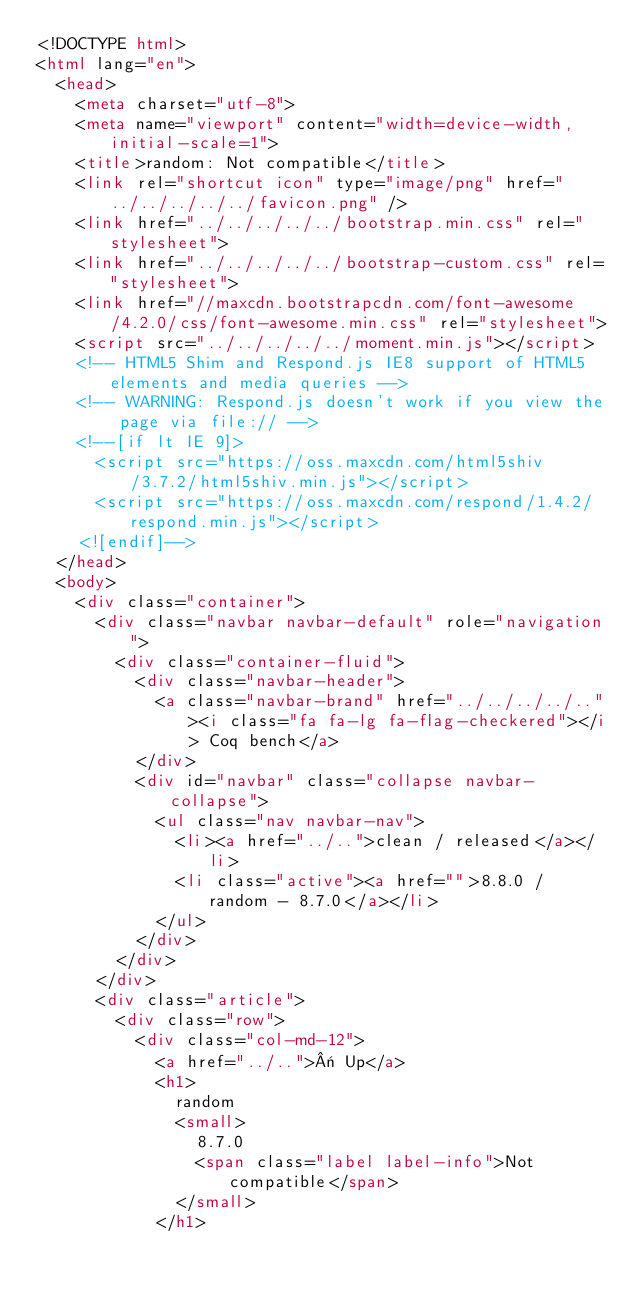<code> <loc_0><loc_0><loc_500><loc_500><_HTML_><!DOCTYPE html>
<html lang="en">
  <head>
    <meta charset="utf-8">
    <meta name="viewport" content="width=device-width, initial-scale=1">
    <title>random: Not compatible</title>
    <link rel="shortcut icon" type="image/png" href="../../../../../favicon.png" />
    <link href="../../../../../bootstrap.min.css" rel="stylesheet">
    <link href="../../../../../bootstrap-custom.css" rel="stylesheet">
    <link href="//maxcdn.bootstrapcdn.com/font-awesome/4.2.0/css/font-awesome.min.css" rel="stylesheet">
    <script src="../../../../../moment.min.js"></script>
    <!-- HTML5 Shim and Respond.js IE8 support of HTML5 elements and media queries -->
    <!-- WARNING: Respond.js doesn't work if you view the page via file:// -->
    <!--[if lt IE 9]>
      <script src="https://oss.maxcdn.com/html5shiv/3.7.2/html5shiv.min.js"></script>
      <script src="https://oss.maxcdn.com/respond/1.4.2/respond.min.js"></script>
    <![endif]-->
  </head>
  <body>
    <div class="container">
      <div class="navbar navbar-default" role="navigation">
        <div class="container-fluid">
          <div class="navbar-header">
            <a class="navbar-brand" href="../../../../.."><i class="fa fa-lg fa-flag-checkered"></i> Coq bench</a>
          </div>
          <div id="navbar" class="collapse navbar-collapse">
            <ul class="nav navbar-nav">
              <li><a href="../..">clean / released</a></li>
              <li class="active"><a href="">8.8.0 / random - 8.7.0</a></li>
            </ul>
          </div>
        </div>
      </div>
      <div class="article">
        <div class="row">
          <div class="col-md-12">
            <a href="../..">« Up</a>
            <h1>
              random
              <small>
                8.7.0
                <span class="label label-info">Not compatible</span>
              </small>
            </h1></code> 